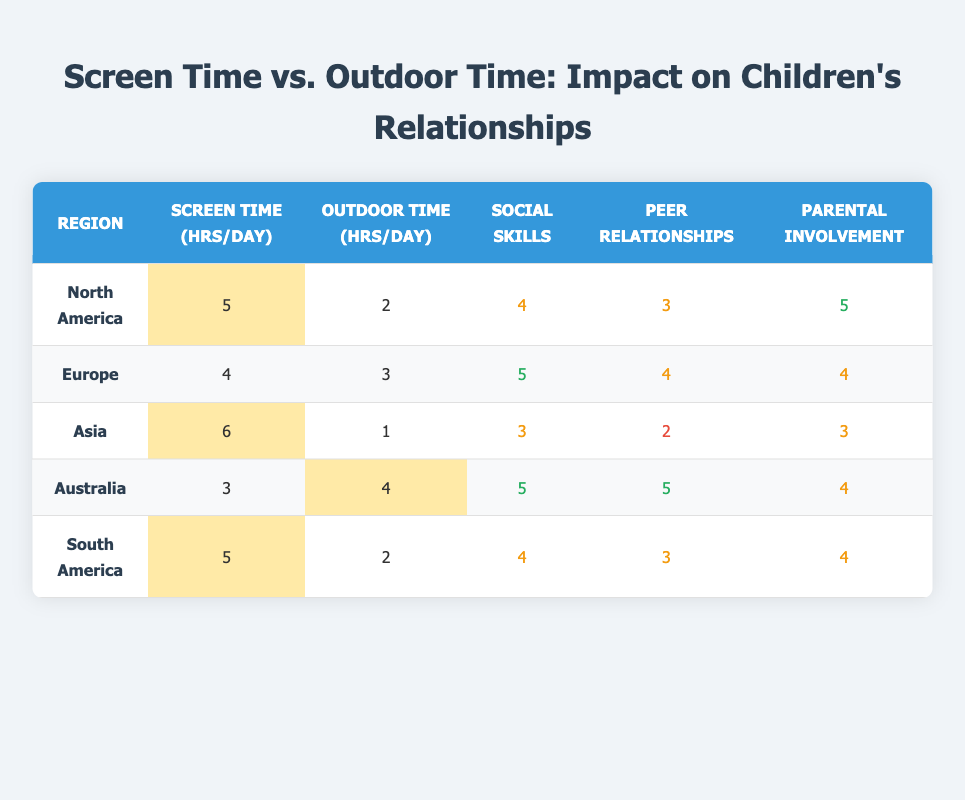What is the average screen time for children in North America? According to the table, the average screen time for children in North America is given as 5 hours per day.
Answer: 5 hours What is the average outdoor time for children in Australia? The table shows that the average outdoor time for children in Australia is 4 hours per day.
Answer: 4 hours Which region has the highest social skill rating? In the table, Europe and Australia both have the highest social skill rating of 5.
Answer: Europe and Australia What is the difference in average screen time between Asia and Europe? The average screen time for Asia is 6 hours, and for Europe, it is 4 hours. The difference is 6 - 4 = 2 hours.
Answer: 2 hours What is the total average outdoor time across all regions? The average outdoor time from all regions is calculated by summing each region's outdoor time: 2 + 3 + 1 + 4 + 2 = 12 hours. With 5 regions, the average is 12 / 5 = 2.4 hours.
Answer: 2.4 hours Do children in Asia have better peer relationships than those in North America? In Asia, the peer relationship quality rating is 2, while in North America, it is 3. Since 3 is greater than 2, this statement is false.
Answer: No In terms of parental involvement, which region has the highest rating? The table indicates that North America has a parental involvement rating of 5, which is the highest compared to other regions.
Answer: North America Is there a clear relationship between screen time and social skill ratings among the regions? Analyzing the table, the regions with higher screen time (like Asia at 6 hours) have lower social skill ratings (3), while regions with lower screen time (like Australia at 3 hours) have higher ratings (5). This suggests an inverse relationship.
Answer: Yes What is the average social skill rating for regions with more than 4 hours of outdoor time? The regions with more than 4 hours of outdoor time are Australia (5) with a 5 social skills rating and Europe (4) with a 5 social skills rating. The average is (5 + 5) / 2 = 5.
Answer: 5 Which region has the lowest peer relationship quality? Based on the table, Asia has the lowest peer relationship quality rating of 2.
Answer: Asia 